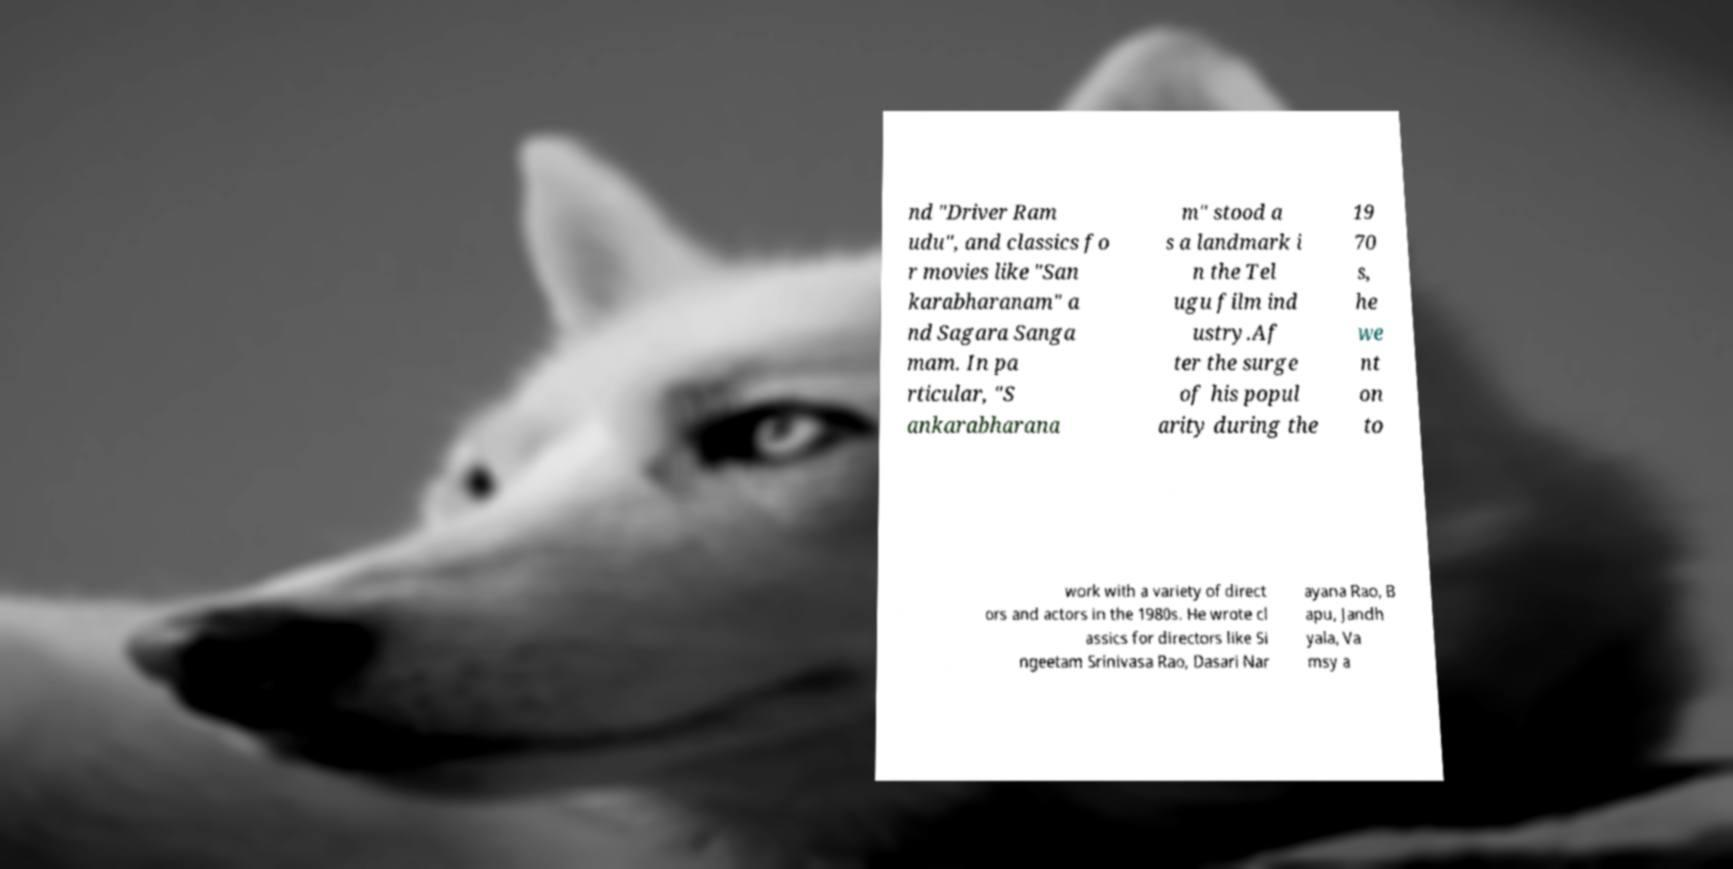What messages or text are displayed in this image? I need them in a readable, typed format. nd "Driver Ram udu", and classics fo r movies like "San karabharanam" a nd Sagara Sanga mam. In pa rticular, "S ankarabharana m" stood a s a landmark i n the Tel ugu film ind ustry.Af ter the surge of his popul arity during the 19 70 s, he we nt on to work with a variety of direct ors and actors in the 1980s. He wrote cl assics for directors like Si ngeetam Srinivasa Rao, Dasari Nar ayana Rao, B apu, Jandh yala, Va msy a 